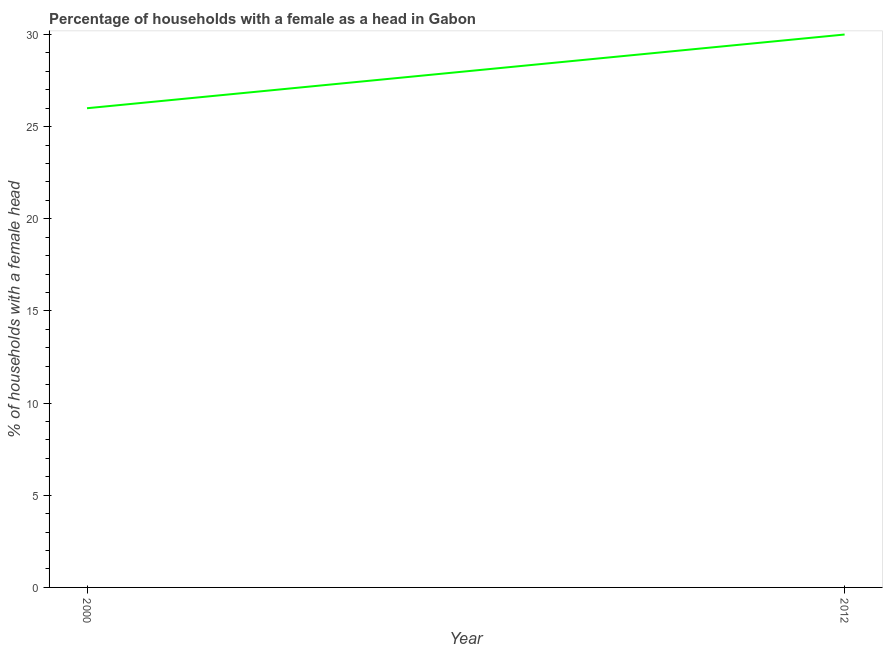What is the number of female supervised households in 2012?
Your answer should be very brief. 30. Across all years, what is the maximum number of female supervised households?
Your answer should be very brief. 30. Across all years, what is the minimum number of female supervised households?
Ensure brevity in your answer.  26. What is the sum of the number of female supervised households?
Provide a short and direct response. 56. What is the difference between the number of female supervised households in 2000 and 2012?
Provide a succinct answer. -4. What is the median number of female supervised households?
Make the answer very short. 28. In how many years, is the number of female supervised households greater than 11 %?
Provide a short and direct response. 2. Do a majority of the years between 2000 and 2012 (inclusive) have number of female supervised households greater than 2 %?
Your answer should be very brief. Yes. What is the ratio of the number of female supervised households in 2000 to that in 2012?
Your answer should be compact. 0.87. In how many years, is the number of female supervised households greater than the average number of female supervised households taken over all years?
Your answer should be compact. 1. How many lines are there?
Keep it short and to the point. 1. What is the difference between two consecutive major ticks on the Y-axis?
Provide a short and direct response. 5. Does the graph contain grids?
Give a very brief answer. No. What is the title of the graph?
Provide a succinct answer. Percentage of households with a female as a head in Gabon. What is the label or title of the Y-axis?
Make the answer very short. % of households with a female head. What is the ratio of the % of households with a female head in 2000 to that in 2012?
Your answer should be compact. 0.87. 